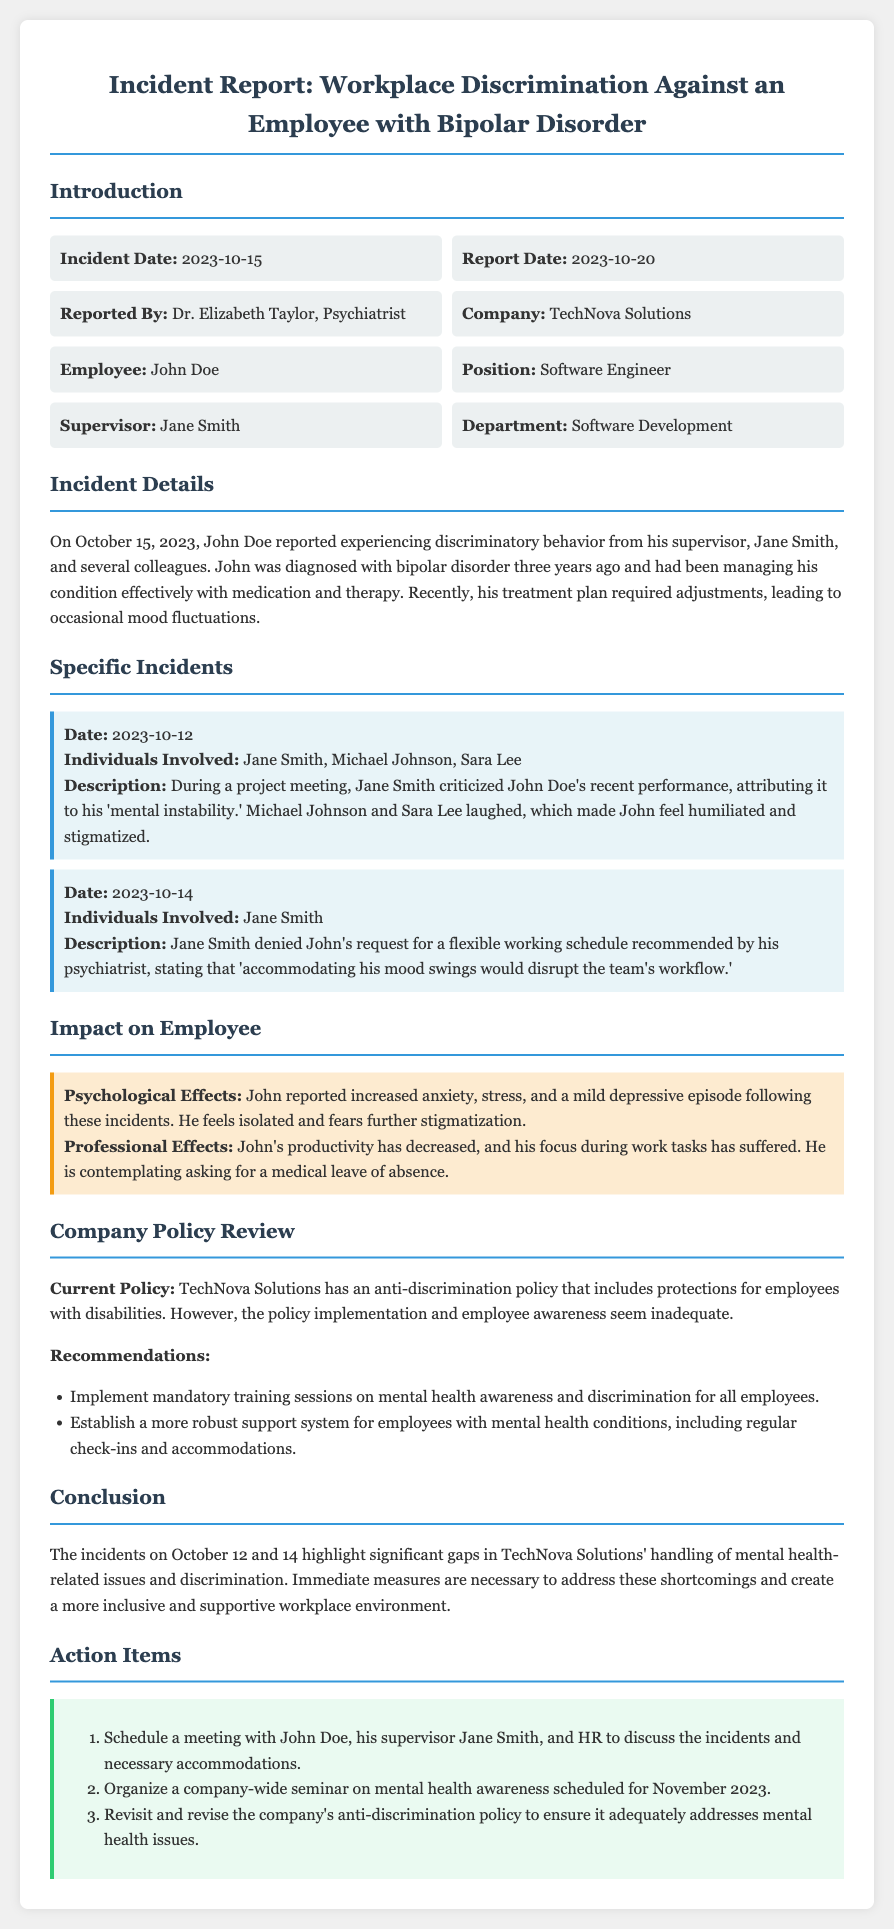What is the incident date? The incident date is mentioned at the beginning of the report, specifically stating it occurred on October 15, 2023.
Answer: October 15, 2023 Who reported the incident? The report specifies that the incident was reported by Dr. Elizabeth Taylor, who is identified as a psychiatrist.
Answer: Dr. Elizabeth Taylor What position does John Doe hold? John Doe's position is stated as a software engineer in the report.
Answer: Software Engineer What discriminatory behavior did Jane Smith exhibit on October 12? The report describes Jane Smith criticizing John Doe’s performance during a meeting, linking it to his mental health condition, while colleagues laughed, leading to John's humiliation.
Answer: Criticized performance due to 'mental instability' What are the psychological effects reported by John? The report lists increased anxiety, stress, and a mild depressive episode as the psychological effects John experienced after the incidents.
Answer: Increased anxiety, stress, mild depressive episode What recommendation is made regarding training sessions? The report recommends implementing mandatory training sessions focused on mental health awareness and discrimination for all employees.
Answer: Mandatory training sessions on mental health awareness How many incidents were specified in the report? Two incidents are detailed in the report, each occurring on separate dates leading up to the overall incident date.
Answer: Two incidents What is TechNova Solutions' current policy regarding discrimination? The report notes that TechNova Solutions has an anti-discrimination policy that includes protections for employees with disabilities.
Answer: Anti-discrimination policy for employees with disabilities What action item involves John Doe? One action item explicitly states that a meeting should be scheduled with John Doe, his supervisor Jane Smith, and HR to discuss the incidents.
Answer: Schedule a meeting with John Doe, Jane Smith, and HR 